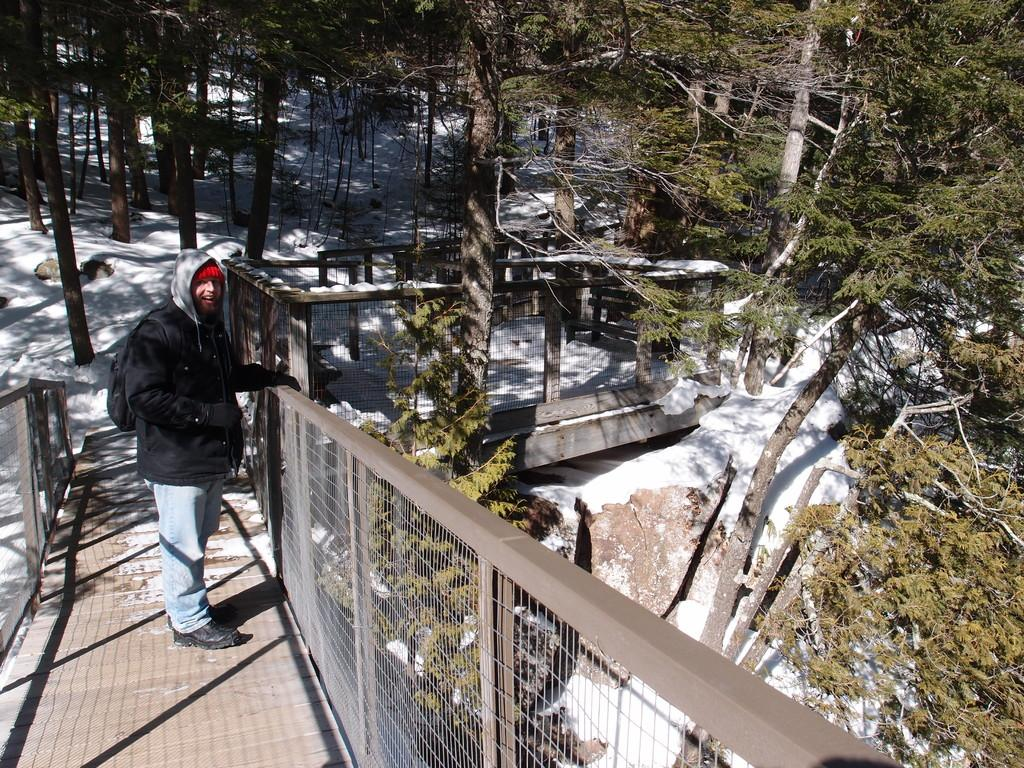What type of natural elements can be seen in the image? There are trees in the image. Where is the person located in the image? The person is on the left side of the image. What is the person wearing? The person is wearing clothes. What structure is the person standing on? The person is standing on a bridge. What object is in the middle of the image? There is a cage in the middle of the image. What note is the person playing on the instrument in the image? There is no instrument present in the image, so it is not possible to determine what note the person might be playing. 